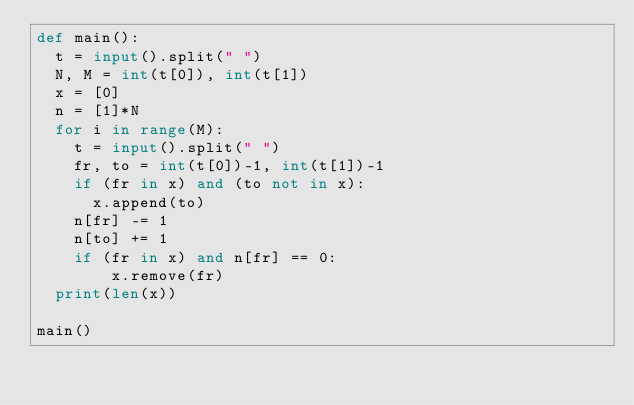<code> <loc_0><loc_0><loc_500><loc_500><_Python_>def main():
  t = input().split(" ")
  N, M = int(t[0]), int(t[1])
  x = [0]
  n = [1]*N
  for i in range(M):
    t = input().split(" ")
    fr, to = int(t[0])-1, int(t[1])-1
    if (fr in x) and (to not in x):
      x.append(to)
    n[fr] -= 1
    n[to] += 1
    if (fr in x) and n[fr] == 0:
        x.remove(fr)
  print(len(x))

main()
</code> 